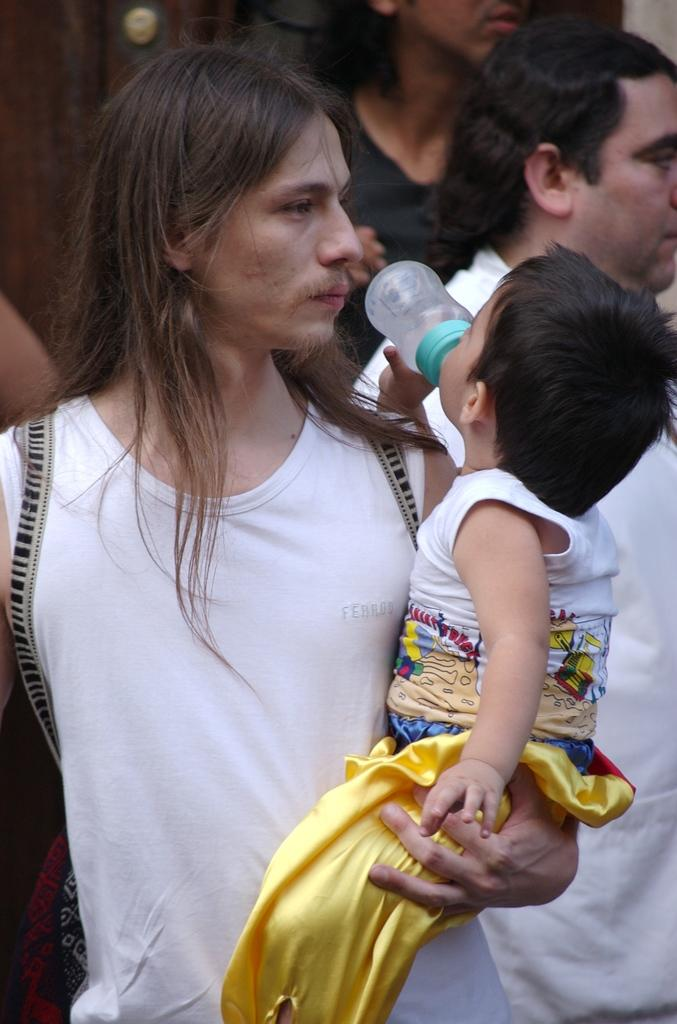What is the appearance of the man in the image? There is a man with long hair in the image. What is the man doing in the image? The man is holding a baby. What is the baby doing in the image? The baby is consuming milk. How many men are present in the image? There are several men in the image. What can be seen in the background of the image? The background of the image is visible. What type of stitch is being used to sew the baby's clothes in the image? There is no indication of any sewing or clothes in the image; the baby is consuming milk while being held by the man. 